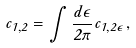<formula> <loc_0><loc_0><loc_500><loc_500>c _ { 1 , 2 } = \int \frac { d \epsilon } { 2 \pi } c _ { 1 , 2 \epsilon } ,</formula> 